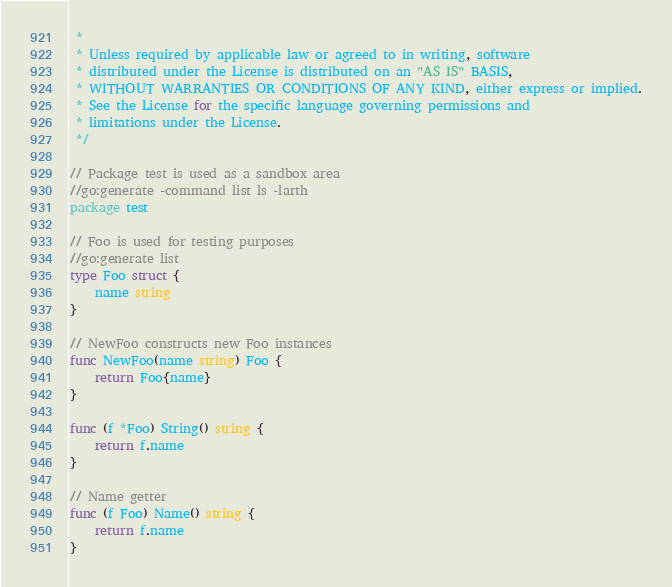Convert code to text. <code><loc_0><loc_0><loc_500><loc_500><_Go_> *
 * Unless required by applicable law or agreed to in writing, software
 * distributed under the License is distributed on an "AS IS" BASIS,
 * WITHOUT WARRANTIES OR CONDITIONS OF ANY KIND, either express or implied.
 * See the License for the specific language governing permissions and
 * limitations under the License.
 */

// Package test is used as a sandbox area
//go:generate -command list ls -larth
package test

// Foo is used for testing purposes
//go:generate list
type Foo struct {
	name string
}

// NewFoo constructs new Foo instances
func NewFoo(name string) Foo {
	return Foo{name}
}

func (f *Foo) String() string {
	return f.name
}

// Name getter
func (f Foo) Name() string {
	return f.name
}
</code> 